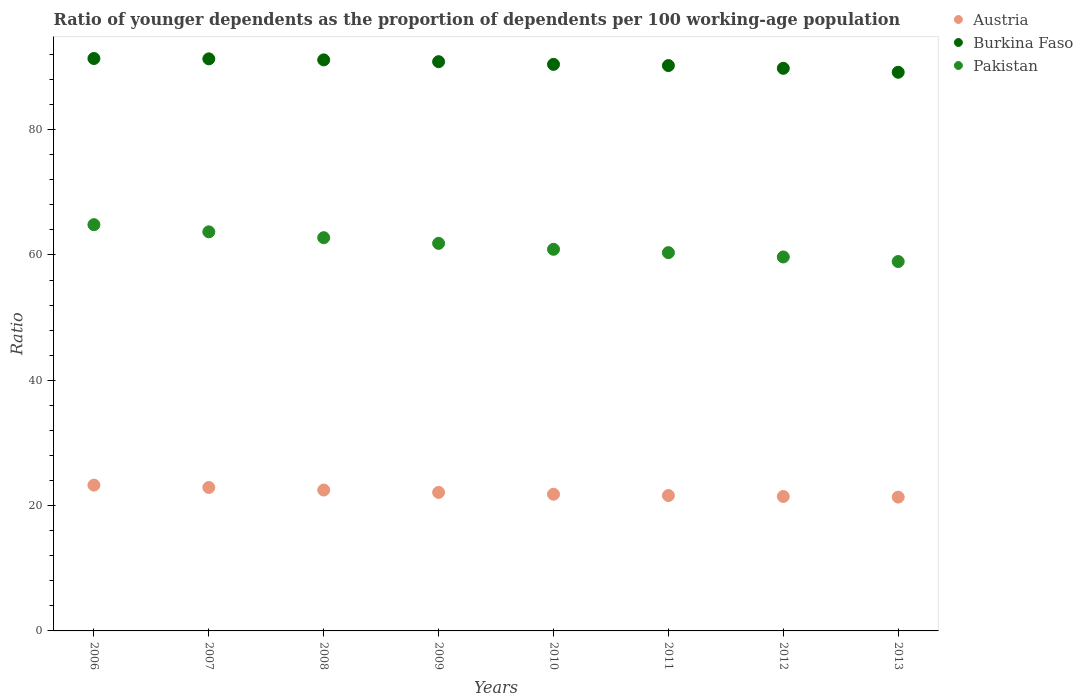How many different coloured dotlines are there?
Give a very brief answer. 3. What is the age dependency ratio(young) in Austria in 2013?
Provide a short and direct response. 21.36. Across all years, what is the maximum age dependency ratio(young) in Austria?
Keep it short and to the point. 23.27. Across all years, what is the minimum age dependency ratio(young) in Pakistan?
Offer a terse response. 58.96. In which year was the age dependency ratio(young) in Pakistan maximum?
Offer a terse response. 2006. In which year was the age dependency ratio(young) in Austria minimum?
Offer a very short reply. 2013. What is the total age dependency ratio(young) in Burkina Faso in the graph?
Your answer should be very brief. 724.26. What is the difference between the age dependency ratio(young) in Burkina Faso in 2011 and that in 2013?
Give a very brief answer. 1.07. What is the difference between the age dependency ratio(young) in Burkina Faso in 2008 and the age dependency ratio(young) in Austria in 2009?
Make the answer very short. 69.03. What is the average age dependency ratio(young) in Pakistan per year?
Ensure brevity in your answer.  61.63. In the year 2013, what is the difference between the age dependency ratio(young) in Austria and age dependency ratio(young) in Pakistan?
Your answer should be compact. -37.6. In how many years, is the age dependency ratio(young) in Pakistan greater than 8?
Offer a very short reply. 8. What is the ratio of the age dependency ratio(young) in Burkina Faso in 2007 to that in 2009?
Offer a terse response. 1. Is the difference between the age dependency ratio(young) in Austria in 2009 and 2013 greater than the difference between the age dependency ratio(young) in Pakistan in 2009 and 2013?
Provide a short and direct response. No. What is the difference between the highest and the second highest age dependency ratio(young) in Pakistan?
Provide a short and direct response. 1.14. What is the difference between the highest and the lowest age dependency ratio(young) in Burkina Faso?
Give a very brief answer. 2.2. In how many years, is the age dependency ratio(young) in Austria greater than the average age dependency ratio(young) in Austria taken over all years?
Provide a short and direct response. 3. Is it the case that in every year, the sum of the age dependency ratio(young) in Burkina Faso and age dependency ratio(young) in Austria  is greater than the age dependency ratio(young) in Pakistan?
Your response must be concise. Yes. Does the age dependency ratio(young) in Austria monotonically increase over the years?
Offer a terse response. No. Is the age dependency ratio(young) in Burkina Faso strictly greater than the age dependency ratio(young) in Pakistan over the years?
Offer a very short reply. Yes. Is the age dependency ratio(young) in Burkina Faso strictly less than the age dependency ratio(young) in Pakistan over the years?
Ensure brevity in your answer.  No. How many dotlines are there?
Provide a succinct answer. 3. What is the difference between two consecutive major ticks on the Y-axis?
Offer a terse response. 20. What is the title of the graph?
Make the answer very short. Ratio of younger dependents as the proportion of dependents per 100 working-age population. What is the label or title of the Y-axis?
Keep it short and to the point. Ratio. What is the Ratio in Austria in 2006?
Provide a short and direct response. 23.27. What is the Ratio of Burkina Faso in 2006?
Your answer should be compact. 91.36. What is the Ratio in Pakistan in 2006?
Your answer should be compact. 64.84. What is the Ratio of Austria in 2007?
Offer a very short reply. 22.9. What is the Ratio of Burkina Faso in 2007?
Your answer should be compact. 91.3. What is the Ratio of Pakistan in 2007?
Your answer should be compact. 63.7. What is the Ratio in Austria in 2008?
Offer a very short reply. 22.48. What is the Ratio in Burkina Faso in 2008?
Keep it short and to the point. 91.14. What is the Ratio of Pakistan in 2008?
Offer a terse response. 62.76. What is the Ratio of Austria in 2009?
Ensure brevity in your answer.  22.11. What is the Ratio in Burkina Faso in 2009?
Offer a very short reply. 90.85. What is the Ratio of Pakistan in 2009?
Keep it short and to the point. 61.85. What is the Ratio in Austria in 2010?
Provide a succinct answer. 21.81. What is the Ratio of Burkina Faso in 2010?
Make the answer very short. 90.42. What is the Ratio of Pakistan in 2010?
Offer a terse response. 60.91. What is the Ratio of Austria in 2011?
Offer a terse response. 21.61. What is the Ratio in Burkina Faso in 2011?
Make the answer very short. 90.23. What is the Ratio in Pakistan in 2011?
Give a very brief answer. 60.37. What is the Ratio in Austria in 2012?
Make the answer very short. 21.46. What is the Ratio in Burkina Faso in 2012?
Provide a succinct answer. 89.79. What is the Ratio in Pakistan in 2012?
Your answer should be compact. 59.68. What is the Ratio in Austria in 2013?
Make the answer very short. 21.36. What is the Ratio of Burkina Faso in 2013?
Keep it short and to the point. 89.16. What is the Ratio of Pakistan in 2013?
Provide a short and direct response. 58.96. Across all years, what is the maximum Ratio in Austria?
Your response must be concise. 23.27. Across all years, what is the maximum Ratio in Burkina Faso?
Offer a terse response. 91.36. Across all years, what is the maximum Ratio of Pakistan?
Ensure brevity in your answer.  64.84. Across all years, what is the minimum Ratio in Austria?
Offer a very short reply. 21.36. Across all years, what is the minimum Ratio in Burkina Faso?
Offer a terse response. 89.16. Across all years, what is the minimum Ratio in Pakistan?
Offer a very short reply. 58.96. What is the total Ratio of Austria in the graph?
Offer a very short reply. 176.99. What is the total Ratio of Burkina Faso in the graph?
Ensure brevity in your answer.  724.26. What is the total Ratio in Pakistan in the graph?
Provide a short and direct response. 493.07. What is the difference between the Ratio in Austria in 2006 and that in 2007?
Your answer should be very brief. 0.37. What is the difference between the Ratio in Burkina Faso in 2006 and that in 2007?
Keep it short and to the point. 0.06. What is the difference between the Ratio of Pakistan in 2006 and that in 2007?
Ensure brevity in your answer.  1.14. What is the difference between the Ratio of Austria in 2006 and that in 2008?
Offer a very short reply. 0.78. What is the difference between the Ratio in Burkina Faso in 2006 and that in 2008?
Provide a succinct answer. 0.22. What is the difference between the Ratio in Pakistan in 2006 and that in 2008?
Ensure brevity in your answer.  2.08. What is the difference between the Ratio of Austria in 2006 and that in 2009?
Make the answer very short. 1.16. What is the difference between the Ratio in Burkina Faso in 2006 and that in 2009?
Ensure brevity in your answer.  0.51. What is the difference between the Ratio of Pakistan in 2006 and that in 2009?
Ensure brevity in your answer.  2.99. What is the difference between the Ratio in Austria in 2006 and that in 2010?
Provide a succinct answer. 1.46. What is the difference between the Ratio of Burkina Faso in 2006 and that in 2010?
Provide a succinct answer. 0.94. What is the difference between the Ratio of Pakistan in 2006 and that in 2010?
Offer a terse response. 3.93. What is the difference between the Ratio in Austria in 2006 and that in 2011?
Your answer should be very brief. 1.66. What is the difference between the Ratio in Burkina Faso in 2006 and that in 2011?
Keep it short and to the point. 1.13. What is the difference between the Ratio in Pakistan in 2006 and that in 2011?
Keep it short and to the point. 4.47. What is the difference between the Ratio of Austria in 2006 and that in 2012?
Offer a very short reply. 1.81. What is the difference between the Ratio in Burkina Faso in 2006 and that in 2012?
Give a very brief answer. 1.57. What is the difference between the Ratio of Pakistan in 2006 and that in 2012?
Provide a short and direct response. 5.16. What is the difference between the Ratio in Austria in 2006 and that in 2013?
Your answer should be very brief. 1.91. What is the difference between the Ratio of Burkina Faso in 2006 and that in 2013?
Your answer should be very brief. 2.2. What is the difference between the Ratio in Pakistan in 2006 and that in 2013?
Keep it short and to the point. 5.88. What is the difference between the Ratio in Austria in 2007 and that in 2008?
Provide a succinct answer. 0.41. What is the difference between the Ratio of Burkina Faso in 2007 and that in 2008?
Give a very brief answer. 0.16. What is the difference between the Ratio of Pakistan in 2007 and that in 2008?
Give a very brief answer. 0.93. What is the difference between the Ratio in Austria in 2007 and that in 2009?
Your answer should be compact. 0.79. What is the difference between the Ratio of Burkina Faso in 2007 and that in 2009?
Your answer should be compact. 0.45. What is the difference between the Ratio of Pakistan in 2007 and that in 2009?
Give a very brief answer. 1.84. What is the difference between the Ratio of Austria in 2007 and that in 2010?
Ensure brevity in your answer.  1.09. What is the difference between the Ratio of Burkina Faso in 2007 and that in 2010?
Offer a terse response. 0.88. What is the difference between the Ratio of Pakistan in 2007 and that in 2010?
Make the answer very short. 2.79. What is the difference between the Ratio of Austria in 2007 and that in 2011?
Your answer should be very brief. 1.29. What is the difference between the Ratio of Burkina Faso in 2007 and that in 2011?
Offer a very short reply. 1.07. What is the difference between the Ratio of Pakistan in 2007 and that in 2011?
Ensure brevity in your answer.  3.32. What is the difference between the Ratio in Austria in 2007 and that in 2012?
Provide a short and direct response. 1.44. What is the difference between the Ratio in Burkina Faso in 2007 and that in 2012?
Offer a very short reply. 1.51. What is the difference between the Ratio in Pakistan in 2007 and that in 2012?
Provide a succinct answer. 4.01. What is the difference between the Ratio in Austria in 2007 and that in 2013?
Offer a very short reply. 1.54. What is the difference between the Ratio of Burkina Faso in 2007 and that in 2013?
Provide a short and direct response. 2.14. What is the difference between the Ratio in Pakistan in 2007 and that in 2013?
Offer a terse response. 4.74. What is the difference between the Ratio of Austria in 2008 and that in 2009?
Provide a succinct answer. 0.38. What is the difference between the Ratio of Burkina Faso in 2008 and that in 2009?
Give a very brief answer. 0.29. What is the difference between the Ratio in Pakistan in 2008 and that in 2009?
Make the answer very short. 0.91. What is the difference between the Ratio of Austria in 2008 and that in 2010?
Your answer should be very brief. 0.67. What is the difference between the Ratio of Burkina Faso in 2008 and that in 2010?
Make the answer very short. 0.72. What is the difference between the Ratio of Pakistan in 2008 and that in 2010?
Your answer should be compact. 1.85. What is the difference between the Ratio in Austria in 2008 and that in 2011?
Ensure brevity in your answer.  0.88. What is the difference between the Ratio of Pakistan in 2008 and that in 2011?
Offer a very short reply. 2.39. What is the difference between the Ratio of Austria in 2008 and that in 2012?
Offer a very short reply. 1.03. What is the difference between the Ratio in Burkina Faso in 2008 and that in 2012?
Offer a terse response. 1.35. What is the difference between the Ratio of Pakistan in 2008 and that in 2012?
Your answer should be compact. 3.08. What is the difference between the Ratio in Austria in 2008 and that in 2013?
Provide a short and direct response. 1.13. What is the difference between the Ratio in Burkina Faso in 2008 and that in 2013?
Provide a succinct answer. 1.98. What is the difference between the Ratio in Pakistan in 2008 and that in 2013?
Offer a terse response. 3.81. What is the difference between the Ratio of Austria in 2009 and that in 2010?
Keep it short and to the point. 0.3. What is the difference between the Ratio in Burkina Faso in 2009 and that in 2010?
Make the answer very short. 0.43. What is the difference between the Ratio in Pakistan in 2009 and that in 2010?
Provide a short and direct response. 0.95. What is the difference between the Ratio of Austria in 2009 and that in 2011?
Make the answer very short. 0.5. What is the difference between the Ratio of Burkina Faso in 2009 and that in 2011?
Provide a succinct answer. 0.62. What is the difference between the Ratio in Pakistan in 2009 and that in 2011?
Your answer should be compact. 1.48. What is the difference between the Ratio in Austria in 2009 and that in 2012?
Your answer should be very brief. 0.65. What is the difference between the Ratio in Burkina Faso in 2009 and that in 2012?
Your answer should be compact. 1.06. What is the difference between the Ratio in Pakistan in 2009 and that in 2012?
Your response must be concise. 2.17. What is the difference between the Ratio in Austria in 2009 and that in 2013?
Offer a terse response. 0.75. What is the difference between the Ratio in Burkina Faso in 2009 and that in 2013?
Make the answer very short. 1.69. What is the difference between the Ratio of Pakistan in 2009 and that in 2013?
Your answer should be very brief. 2.9. What is the difference between the Ratio of Austria in 2010 and that in 2011?
Ensure brevity in your answer.  0.2. What is the difference between the Ratio of Burkina Faso in 2010 and that in 2011?
Make the answer very short. 0.19. What is the difference between the Ratio of Pakistan in 2010 and that in 2011?
Your answer should be very brief. 0.54. What is the difference between the Ratio in Austria in 2010 and that in 2012?
Your answer should be very brief. 0.35. What is the difference between the Ratio of Burkina Faso in 2010 and that in 2012?
Offer a terse response. 0.63. What is the difference between the Ratio in Pakistan in 2010 and that in 2012?
Offer a terse response. 1.23. What is the difference between the Ratio in Austria in 2010 and that in 2013?
Offer a very short reply. 0.46. What is the difference between the Ratio in Burkina Faso in 2010 and that in 2013?
Provide a short and direct response. 1.26. What is the difference between the Ratio of Pakistan in 2010 and that in 2013?
Provide a succinct answer. 1.95. What is the difference between the Ratio of Austria in 2011 and that in 2012?
Give a very brief answer. 0.15. What is the difference between the Ratio in Burkina Faso in 2011 and that in 2012?
Provide a succinct answer. 0.44. What is the difference between the Ratio in Pakistan in 2011 and that in 2012?
Offer a very short reply. 0.69. What is the difference between the Ratio of Austria in 2011 and that in 2013?
Make the answer very short. 0.25. What is the difference between the Ratio of Burkina Faso in 2011 and that in 2013?
Ensure brevity in your answer.  1.07. What is the difference between the Ratio in Pakistan in 2011 and that in 2013?
Provide a short and direct response. 1.42. What is the difference between the Ratio in Austria in 2012 and that in 2013?
Keep it short and to the point. 0.1. What is the difference between the Ratio of Burkina Faso in 2012 and that in 2013?
Your answer should be compact. 0.63. What is the difference between the Ratio in Pakistan in 2012 and that in 2013?
Provide a succinct answer. 0.73. What is the difference between the Ratio in Austria in 2006 and the Ratio in Burkina Faso in 2007?
Provide a short and direct response. -68.03. What is the difference between the Ratio in Austria in 2006 and the Ratio in Pakistan in 2007?
Make the answer very short. -40.43. What is the difference between the Ratio of Burkina Faso in 2006 and the Ratio of Pakistan in 2007?
Your answer should be very brief. 27.66. What is the difference between the Ratio in Austria in 2006 and the Ratio in Burkina Faso in 2008?
Ensure brevity in your answer.  -67.87. What is the difference between the Ratio of Austria in 2006 and the Ratio of Pakistan in 2008?
Make the answer very short. -39.49. What is the difference between the Ratio of Burkina Faso in 2006 and the Ratio of Pakistan in 2008?
Your response must be concise. 28.6. What is the difference between the Ratio of Austria in 2006 and the Ratio of Burkina Faso in 2009?
Give a very brief answer. -67.58. What is the difference between the Ratio of Austria in 2006 and the Ratio of Pakistan in 2009?
Provide a succinct answer. -38.59. What is the difference between the Ratio of Burkina Faso in 2006 and the Ratio of Pakistan in 2009?
Your answer should be very brief. 29.5. What is the difference between the Ratio of Austria in 2006 and the Ratio of Burkina Faso in 2010?
Provide a short and direct response. -67.15. What is the difference between the Ratio in Austria in 2006 and the Ratio in Pakistan in 2010?
Your answer should be very brief. -37.64. What is the difference between the Ratio of Burkina Faso in 2006 and the Ratio of Pakistan in 2010?
Provide a short and direct response. 30.45. What is the difference between the Ratio in Austria in 2006 and the Ratio in Burkina Faso in 2011?
Offer a very short reply. -66.96. What is the difference between the Ratio in Austria in 2006 and the Ratio in Pakistan in 2011?
Provide a succinct answer. -37.11. What is the difference between the Ratio in Burkina Faso in 2006 and the Ratio in Pakistan in 2011?
Make the answer very short. 30.98. What is the difference between the Ratio in Austria in 2006 and the Ratio in Burkina Faso in 2012?
Give a very brief answer. -66.52. What is the difference between the Ratio of Austria in 2006 and the Ratio of Pakistan in 2012?
Your answer should be very brief. -36.41. What is the difference between the Ratio of Burkina Faso in 2006 and the Ratio of Pakistan in 2012?
Offer a terse response. 31.68. What is the difference between the Ratio of Austria in 2006 and the Ratio of Burkina Faso in 2013?
Provide a short and direct response. -65.89. What is the difference between the Ratio of Austria in 2006 and the Ratio of Pakistan in 2013?
Your answer should be compact. -35.69. What is the difference between the Ratio in Burkina Faso in 2006 and the Ratio in Pakistan in 2013?
Keep it short and to the point. 32.4. What is the difference between the Ratio in Austria in 2007 and the Ratio in Burkina Faso in 2008?
Your response must be concise. -68.24. What is the difference between the Ratio of Austria in 2007 and the Ratio of Pakistan in 2008?
Your answer should be very brief. -39.86. What is the difference between the Ratio of Burkina Faso in 2007 and the Ratio of Pakistan in 2008?
Offer a very short reply. 28.54. What is the difference between the Ratio in Austria in 2007 and the Ratio in Burkina Faso in 2009?
Offer a very short reply. -67.95. What is the difference between the Ratio in Austria in 2007 and the Ratio in Pakistan in 2009?
Your answer should be very brief. -38.96. What is the difference between the Ratio in Burkina Faso in 2007 and the Ratio in Pakistan in 2009?
Provide a succinct answer. 29.45. What is the difference between the Ratio in Austria in 2007 and the Ratio in Burkina Faso in 2010?
Ensure brevity in your answer.  -67.52. What is the difference between the Ratio of Austria in 2007 and the Ratio of Pakistan in 2010?
Make the answer very short. -38.01. What is the difference between the Ratio of Burkina Faso in 2007 and the Ratio of Pakistan in 2010?
Make the answer very short. 30.39. What is the difference between the Ratio of Austria in 2007 and the Ratio of Burkina Faso in 2011?
Your answer should be very brief. -67.33. What is the difference between the Ratio in Austria in 2007 and the Ratio in Pakistan in 2011?
Provide a short and direct response. -37.48. What is the difference between the Ratio in Burkina Faso in 2007 and the Ratio in Pakistan in 2011?
Your answer should be very brief. 30.93. What is the difference between the Ratio of Austria in 2007 and the Ratio of Burkina Faso in 2012?
Provide a short and direct response. -66.89. What is the difference between the Ratio in Austria in 2007 and the Ratio in Pakistan in 2012?
Keep it short and to the point. -36.78. What is the difference between the Ratio in Burkina Faso in 2007 and the Ratio in Pakistan in 2012?
Provide a short and direct response. 31.62. What is the difference between the Ratio of Austria in 2007 and the Ratio of Burkina Faso in 2013?
Your answer should be compact. -66.26. What is the difference between the Ratio in Austria in 2007 and the Ratio in Pakistan in 2013?
Give a very brief answer. -36.06. What is the difference between the Ratio of Burkina Faso in 2007 and the Ratio of Pakistan in 2013?
Ensure brevity in your answer.  32.35. What is the difference between the Ratio of Austria in 2008 and the Ratio of Burkina Faso in 2009?
Your response must be concise. -68.37. What is the difference between the Ratio of Austria in 2008 and the Ratio of Pakistan in 2009?
Give a very brief answer. -39.37. What is the difference between the Ratio of Burkina Faso in 2008 and the Ratio of Pakistan in 2009?
Offer a terse response. 29.28. What is the difference between the Ratio in Austria in 2008 and the Ratio in Burkina Faso in 2010?
Keep it short and to the point. -67.94. What is the difference between the Ratio of Austria in 2008 and the Ratio of Pakistan in 2010?
Your answer should be very brief. -38.42. What is the difference between the Ratio in Burkina Faso in 2008 and the Ratio in Pakistan in 2010?
Offer a very short reply. 30.23. What is the difference between the Ratio in Austria in 2008 and the Ratio in Burkina Faso in 2011?
Your answer should be compact. -67.75. What is the difference between the Ratio in Austria in 2008 and the Ratio in Pakistan in 2011?
Your response must be concise. -37.89. What is the difference between the Ratio of Burkina Faso in 2008 and the Ratio of Pakistan in 2011?
Offer a very short reply. 30.77. What is the difference between the Ratio of Austria in 2008 and the Ratio of Burkina Faso in 2012?
Offer a very short reply. -67.31. What is the difference between the Ratio in Austria in 2008 and the Ratio in Pakistan in 2012?
Give a very brief answer. -37.2. What is the difference between the Ratio of Burkina Faso in 2008 and the Ratio of Pakistan in 2012?
Make the answer very short. 31.46. What is the difference between the Ratio of Austria in 2008 and the Ratio of Burkina Faso in 2013?
Offer a very short reply. -66.68. What is the difference between the Ratio in Austria in 2008 and the Ratio in Pakistan in 2013?
Make the answer very short. -36.47. What is the difference between the Ratio in Burkina Faso in 2008 and the Ratio in Pakistan in 2013?
Offer a terse response. 32.18. What is the difference between the Ratio of Austria in 2009 and the Ratio of Burkina Faso in 2010?
Offer a very short reply. -68.31. What is the difference between the Ratio in Austria in 2009 and the Ratio in Pakistan in 2010?
Your answer should be compact. -38.8. What is the difference between the Ratio of Burkina Faso in 2009 and the Ratio of Pakistan in 2010?
Offer a very short reply. 29.94. What is the difference between the Ratio of Austria in 2009 and the Ratio of Burkina Faso in 2011?
Keep it short and to the point. -68.12. What is the difference between the Ratio of Austria in 2009 and the Ratio of Pakistan in 2011?
Ensure brevity in your answer.  -38.27. What is the difference between the Ratio of Burkina Faso in 2009 and the Ratio of Pakistan in 2011?
Provide a short and direct response. 30.48. What is the difference between the Ratio of Austria in 2009 and the Ratio of Burkina Faso in 2012?
Offer a very short reply. -67.68. What is the difference between the Ratio in Austria in 2009 and the Ratio in Pakistan in 2012?
Offer a very short reply. -37.57. What is the difference between the Ratio of Burkina Faso in 2009 and the Ratio of Pakistan in 2012?
Offer a very short reply. 31.17. What is the difference between the Ratio in Austria in 2009 and the Ratio in Burkina Faso in 2013?
Keep it short and to the point. -67.05. What is the difference between the Ratio of Austria in 2009 and the Ratio of Pakistan in 2013?
Keep it short and to the point. -36.85. What is the difference between the Ratio in Burkina Faso in 2009 and the Ratio in Pakistan in 2013?
Keep it short and to the point. 31.9. What is the difference between the Ratio in Austria in 2010 and the Ratio in Burkina Faso in 2011?
Ensure brevity in your answer.  -68.42. What is the difference between the Ratio in Austria in 2010 and the Ratio in Pakistan in 2011?
Make the answer very short. -38.56. What is the difference between the Ratio of Burkina Faso in 2010 and the Ratio of Pakistan in 2011?
Your answer should be very brief. 30.05. What is the difference between the Ratio of Austria in 2010 and the Ratio of Burkina Faso in 2012?
Offer a terse response. -67.98. What is the difference between the Ratio of Austria in 2010 and the Ratio of Pakistan in 2012?
Your response must be concise. -37.87. What is the difference between the Ratio in Burkina Faso in 2010 and the Ratio in Pakistan in 2012?
Provide a succinct answer. 30.74. What is the difference between the Ratio in Austria in 2010 and the Ratio in Burkina Faso in 2013?
Offer a very short reply. -67.35. What is the difference between the Ratio of Austria in 2010 and the Ratio of Pakistan in 2013?
Give a very brief answer. -37.14. What is the difference between the Ratio of Burkina Faso in 2010 and the Ratio of Pakistan in 2013?
Your answer should be very brief. 31.47. What is the difference between the Ratio of Austria in 2011 and the Ratio of Burkina Faso in 2012?
Keep it short and to the point. -68.18. What is the difference between the Ratio in Austria in 2011 and the Ratio in Pakistan in 2012?
Provide a short and direct response. -38.07. What is the difference between the Ratio in Burkina Faso in 2011 and the Ratio in Pakistan in 2012?
Offer a terse response. 30.55. What is the difference between the Ratio in Austria in 2011 and the Ratio in Burkina Faso in 2013?
Provide a short and direct response. -67.55. What is the difference between the Ratio in Austria in 2011 and the Ratio in Pakistan in 2013?
Make the answer very short. -37.35. What is the difference between the Ratio in Burkina Faso in 2011 and the Ratio in Pakistan in 2013?
Your response must be concise. 31.27. What is the difference between the Ratio in Austria in 2012 and the Ratio in Burkina Faso in 2013?
Keep it short and to the point. -67.7. What is the difference between the Ratio in Austria in 2012 and the Ratio in Pakistan in 2013?
Give a very brief answer. -37.5. What is the difference between the Ratio of Burkina Faso in 2012 and the Ratio of Pakistan in 2013?
Offer a very short reply. 30.84. What is the average Ratio in Austria per year?
Provide a succinct answer. 22.12. What is the average Ratio of Burkina Faso per year?
Make the answer very short. 90.53. What is the average Ratio of Pakistan per year?
Your answer should be compact. 61.63. In the year 2006, what is the difference between the Ratio in Austria and Ratio in Burkina Faso?
Keep it short and to the point. -68.09. In the year 2006, what is the difference between the Ratio of Austria and Ratio of Pakistan?
Offer a very short reply. -41.57. In the year 2006, what is the difference between the Ratio of Burkina Faso and Ratio of Pakistan?
Offer a terse response. 26.52. In the year 2007, what is the difference between the Ratio of Austria and Ratio of Burkina Faso?
Give a very brief answer. -68.4. In the year 2007, what is the difference between the Ratio in Austria and Ratio in Pakistan?
Ensure brevity in your answer.  -40.8. In the year 2007, what is the difference between the Ratio in Burkina Faso and Ratio in Pakistan?
Your answer should be compact. 27.61. In the year 2008, what is the difference between the Ratio of Austria and Ratio of Burkina Faso?
Your answer should be very brief. -68.66. In the year 2008, what is the difference between the Ratio in Austria and Ratio in Pakistan?
Your answer should be very brief. -40.28. In the year 2008, what is the difference between the Ratio of Burkina Faso and Ratio of Pakistan?
Your answer should be compact. 28.38. In the year 2009, what is the difference between the Ratio of Austria and Ratio of Burkina Faso?
Give a very brief answer. -68.74. In the year 2009, what is the difference between the Ratio of Austria and Ratio of Pakistan?
Make the answer very short. -39.75. In the year 2009, what is the difference between the Ratio in Burkina Faso and Ratio in Pakistan?
Give a very brief answer. 29. In the year 2010, what is the difference between the Ratio of Austria and Ratio of Burkina Faso?
Provide a short and direct response. -68.61. In the year 2010, what is the difference between the Ratio in Austria and Ratio in Pakistan?
Your answer should be compact. -39.1. In the year 2010, what is the difference between the Ratio of Burkina Faso and Ratio of Pakistan?
Offer a terse response. 29.51. In the year 2011, what is the difference between the Ratio of Austria and Ratio of Burkina Faso?
Provide a short and direct response. -68.62. In the year 2011, what is the difference between the Ratio in Austria and Ratio in Pakistan?
Make the answer very short. -38.77. In the year 2011, what is the difference between the Ratio of Burkina Faso and Ratio of Pakistan?
Offer a very short reply. 29.86. In the year 2012, what is the difference between the Ratio of Austria and Ratio of Burkina Faso?
Provide a succinct answer. -68.33. In the year 2012, what is the difference between the Ratio of Austria and Ratio of Pakistan?
Your answer should be compact. -38.23. In the year 2012, what is the difference between the Ratio of Burkina Faso and Ratio of Pakistan?
Provide a short and direct response. 30.11. In the year 2013, what is the difference between the Ratio in Austria and Ratio in Burkina Faso?
Offer a very short reply. -67.81. In the year 2013, what is the difference between the Ratio in Austria and Ratio in Pakistan?
Give a very brief answer. -37.6. In the year 2013, what is the difference between the Ratio of Burkina Faso and Ratio of Pakistan?
Provide a succinct answer. 30.21. What is the ratio of the Ratio of Austria in 2006 to that in 2007?
Your answer should be very brief. 1.02. What is the ratio of the Ratio in Austria in 2006 to that in 2008?
Keep it short and to the point. 1.03. What is the ratio of the Ratio of Burkina Faso in 2006 to that in 2008?
Provide a succinct answer. 1. What is the ratio of the Ratio of Pakistan in 2006 to that in 2008?
Offer a terse response. 1.03. What is the ratio of the Ratio in Austria in 2006 to that in 2009?
Your answer should be very brief. 1.05. What is the ratio of the Ratio in Burkina Faso in 2006 to that in 2009?
Offer a terse response. 1.01. What is the ratio of the Ratio in Pakistan in 2006 to that in 2009?
Provide a short and direct response. 1.05. What is the ratio of the Ratio in Austria in 2006 to that in 2010?
Keep it short and to the point. 1.07. What is the ratio of the Ratio in Burkina Faso in 2006 to that in 2010?
Give a very brief answer. 1.01. What is the ratio of the Ratio of Pakistan in 2006 to that in 2010?
Make the answer very short. 1.06. What is the ratio of the Ratio in Austria in 2006 to that in 2011?
Keep it short and to the point. 1.08. What is the ratio of the Ratio of Burkina Faso in 2006 to that in 2011?
Your response must be concise. 1.01. What is the ratio of the Ratio in Pakistan in 2006 to that in 2011?
Make the answer very short. 1.07. What is the ratio of the Ratio in Austria in 2006 to that in 2012?
Offer a very short reply. 1.08. What is the ratio of the Ratio of Burkina Faso in 2006 to that in 2012?
Your answer should be very brief. 1.02. What is the ratio of the Ratio of Pakistan in 2006 to that in 2012?
Keep it short and to the point. 1.09. What is the ratio of the Ratio in Austria in 2006 to that in 2013?
Keep it short and to the point. 1.09. What is the ratio of the Ratio in Burkina Faso in 2006 to that in 2013?
Keep it short and to the point. 1.02. What is the ratio of the Ratio in Pakistan in 2006 to that in 2013?
Offer a terse response. 1.1. What is the ratio of the Ratio in Austria in 2007 to that in 2008?
Your response must be concise. 1.02. What is the ratio of the Ratio of Pakistan in 2007 to that in 2008?
Keep it short and to the point. 1.01. What is the ratio of the Ratio in Austria in 2007 to that in 2009?
Provide a short and direct response. 1.04. What is the ratio of the Ratio of Pakistan in 2007 to that in 2009?
Provide a succinct answer. 1.03. What is the ratio of the Ratio in Austria in 2007 to that in 2010?
Your answer should be very brief. 1.05. What is the ratio of the Ratio in Burkina Faso in 2007 to that in 2010?
Provide a succinct answer. 1.01. What is the ratio of the Ratio of Pakistan in 2007 to that in 2010?
Keep it short and to the point. 1.05. What is the ratio of the Ratio of Austria in 2007 to that in 2011?
Provide a short and direct response. 1.06. What is the ratio of the Ratio in Burkina Faso in 2007 to that in 2011?
Provide a short and direct response. 1.01. What is the ratio of the Ratio of Pakistan in 2007 to that in 2011?
Your answer should be very brief. 1.05. What is the ratio of the Ratio of Austria in 2007 to that in 2012?
Ensure brevity in your answer.  1.07. What is the ratio of the Ratio of Burkina Faso in 2007 to that in 2012?
Make the answer very short. 1.02. What is the ratio of the Ratio of Pakistan in 2007 to that in 2012?
Offer a terse response. 1.07. What is the ratio of the Ratio in Austria in 2007 to that in 2013?
Offer a very short reply. 1.07. What is the ratio of the Ratio in Burkina Faso in 2007 to that in 2013?
Make the answer very short. 1.02. What is the ratio of the Ratio in Pakistan in 2007 to that in 2013?
Give a very brief answer. 1.08. What is the ratio of the Ratio in Pakistan in 2008 to that in 2009?
Your answer should be compact. 1.01. What is the ratio of the Ratio of Austria in 2008 to that in 2010?
Provide a short and direct response. 1.03. What is the ratio of the Ratio in Burkina Faso in 2008 to that in 2010?
Your answer should be very brief. 1.01. What is the ratio of the Ratio in Pakistan in 2008 to that in 2010?
Provide a short and direct response. 1.03. What is the ratio of the Ratio in Austria in 2008 to that in 2011?
Make the answer very short. 1.04. What is the ratio of the Ratio in Pakistan in 2008 to that in 2011?
Offer a terse response. 1.04. What is the ratio of the Ratio of Austria in 2008 to that in 2012?
Give a very brief answer. 1.05. What is the ratio of the Ratio of Pakistan in 2008 to that in 2012?
Ensure brevity in your answer.  1.05. What is the ratio of the Ratio in Austria in 2008 to that in 2013?
Give a very brief answer. 1.05. What is the ratio of the Ratio in Burkina Faso in 2008 to that in 2013?
Make the answer very short. 1.02. What is the ratio of the Ratio of Pakistan in 2008 to that in 2013?
Offer a very short reply. 1.06. What is the ratio of the Ratio of Austria in 2009 to that in 2010?
Make the answer very short. 1.01. What is the ratio of the Ratio in Pakistan in 2009 to that in 2010?
Your answer should be very brief. 1.02. What is the ratio of the Ratio of Austria in 2009 to that in 2011?
Offer a terse response. 1.02. What is the ratio of the Ratio in Pakistan in 2009 to that in 2011?
Provide a succinct answer. 1.02. What is the ratio of the Ratio of Austria in 2009 to that in 2012?
Make the answer very short. 1.03. What is the ratio of the Ratio of Burkina Faso in 2009 to that in 2012?
Your answer should be very brief. 1.01. What is the ratio of the Ratio in Pakistan in 2009 to that in 2012?
Ensure brevity in your answer.  1.04. What is the ratio of the Ratio in Austria in 2009 to that in 2013?
Make the answer very short. 1.04. What is the ratio of the Ratio of Pakistan in 2009 to that in 2013?
Offer a very short reply. 1.05. What is the ratio of the Ratio of Austria in 2010 to that in 2011?
Your answer should be compact. 1.01. What is the ratio of the Ratio in Pakistan in 2010 to that in 2011?
Your answer should be compact. 1.01. What is the ratio of the Ratio of Austria in 2010 to that in 2012?
Your answer should be compact. 1.02. What is the ratio of the Ratio in Pakistan in 2010 to that in 2012?
Ensure brevity in your answer.  1.02. What is the ratio of the Ratio in Austria in 2010 to that in 2013?
Provide a succinct answer. 1.02. What is the ratio of the Ratio of Burkina Faso in 2010 to that in 2013?
Make the answer very short. 1.01. What is the ratio of the Ratio in Pakistan in 2010 to that in 2013?
Give a very brief answer. 1.03. What is the ratio of the Ratio in Austria in 2011 to that in 2012?
Keep it short and to the point. 1.01. What is the ratio of the Ratio of Pakistan in 2011 to that in 2012?
Provide a short and direct response. 1.01. What is the ratio of the Ratio in Austria in 2011 to that in 2013?
Make the answer very short. 1.01. What is the ratio of the Ratio of Pakistan in 2011 to that in 2013?
Provide a succinct answer. 1.02. What is the ratio of the Ratio in Austria in 2012 to that in 2013?
Provide a succinct answer. 1. What is the ratio of the Ratio in Burkina Faso in 2012 to that in 2013?
Your answer should be compact. 1.01. What is the ratio of the Ratio in Pakistan in 2012 to that in 2013?
Your answer should be very brief. 1.01. What is the difference between the highest and the second highest Ratio of Austria?
Give a very brief answer. 0.37. What is the difference between the highest and the second highest Ratio of Burkina Faso?
Offer a very short reply. 0.06. What is the difference between the highest and the second highest Ratio in Pakistan?
Keep it short and to the point. 1.14. What is the difference between the highest and the lowest Ratio in Austria?
Keep it short and to the point. 1.91. What is the difference between the highest and the lowest Ratio in Burkina Faso?
Your answer should be compact. 2.2. What is the difference between the highest and the lowest Ratio of Pakistan?
Make the answer very short. 5.88. 